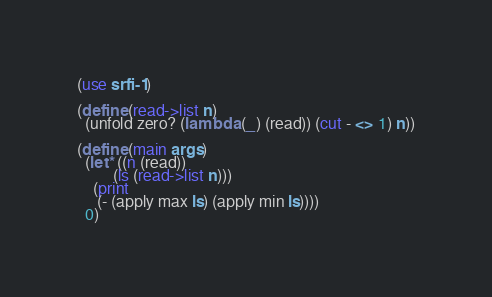Convert code to text. <code><loc_0><loc_0><loc_500><loc_500><_Scheme_>(use srfi-1)

(define (read->list n)
  (unfold zero? (lambda (_) (read)) (cut - <> 1) n))

(define (main args)
  (let* ((n (read))
         (ls (read->list n)))
    (print
     (- (apply max ls) (apply min ls))))
  0)
</code> 